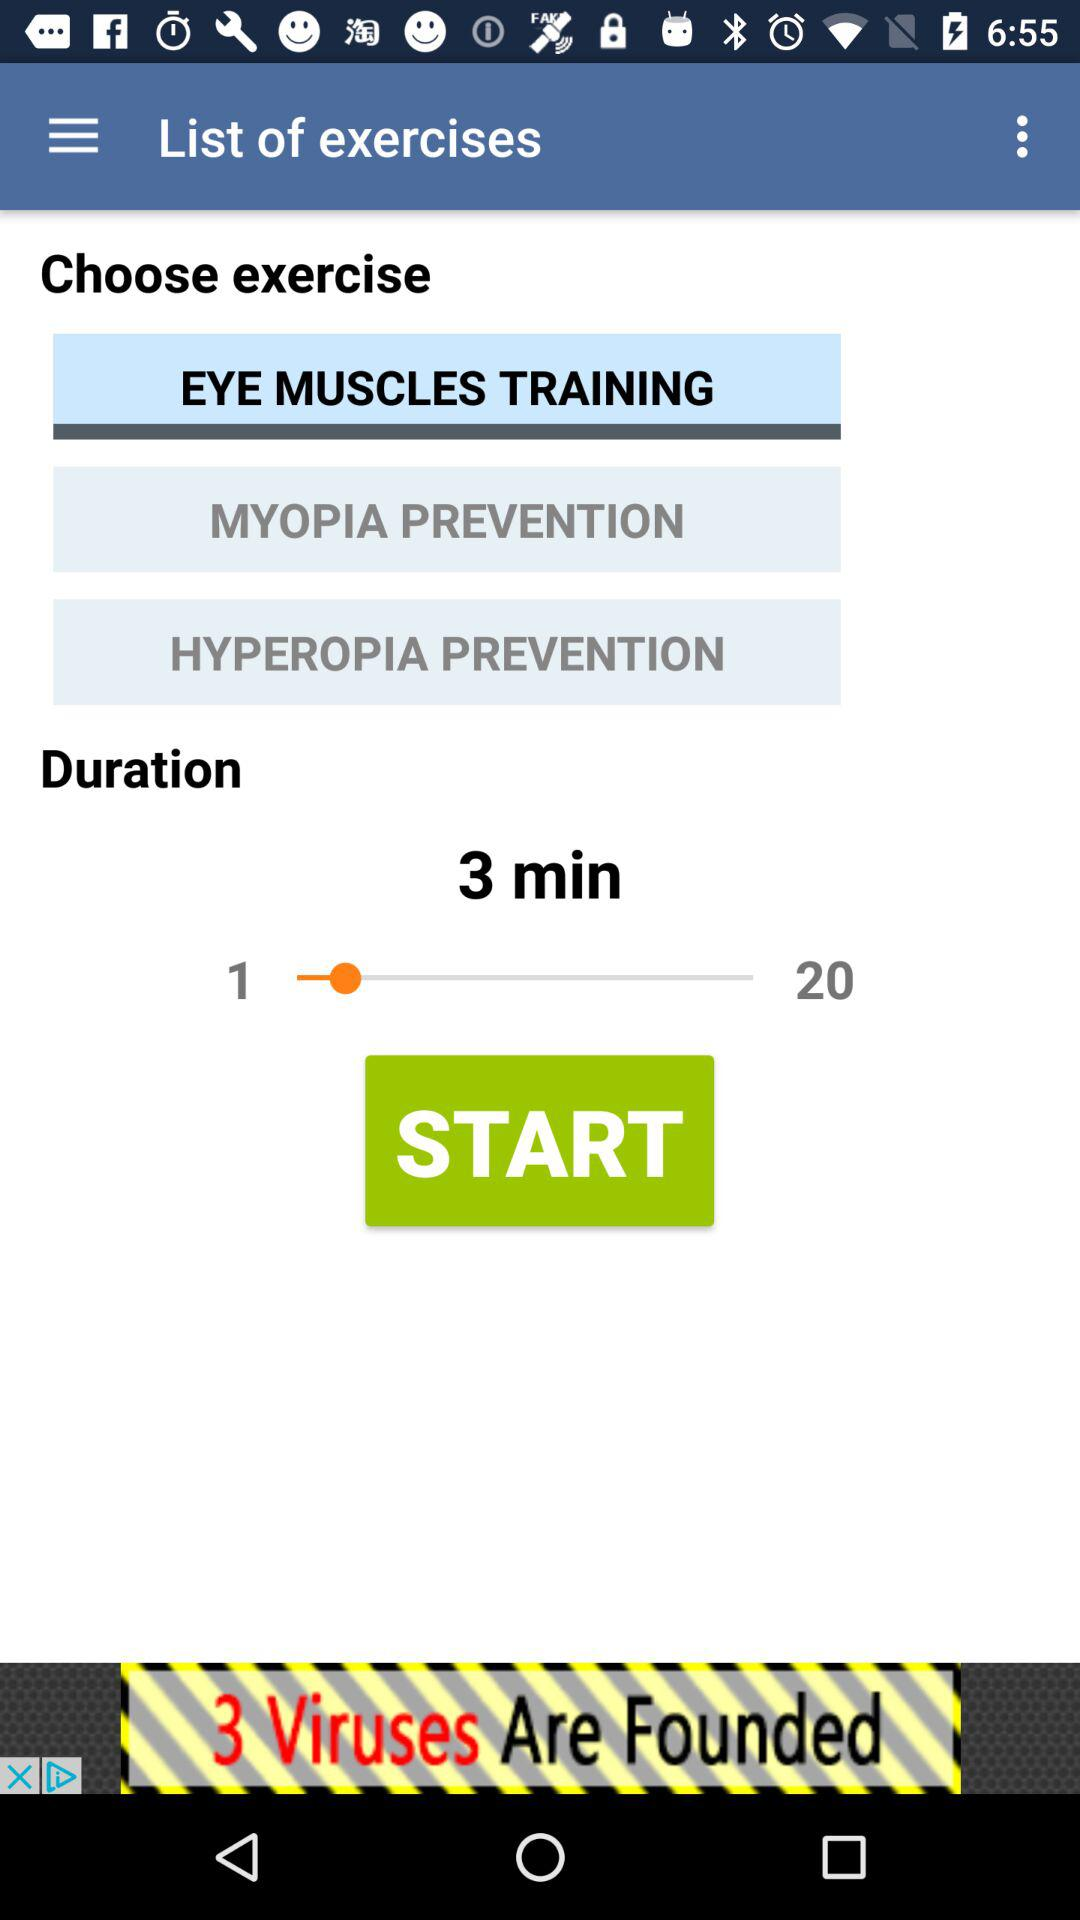How many exercises are required to complete eye muscle training?
When the provided information is insufficient, respond with <no answer>. <no answer> 